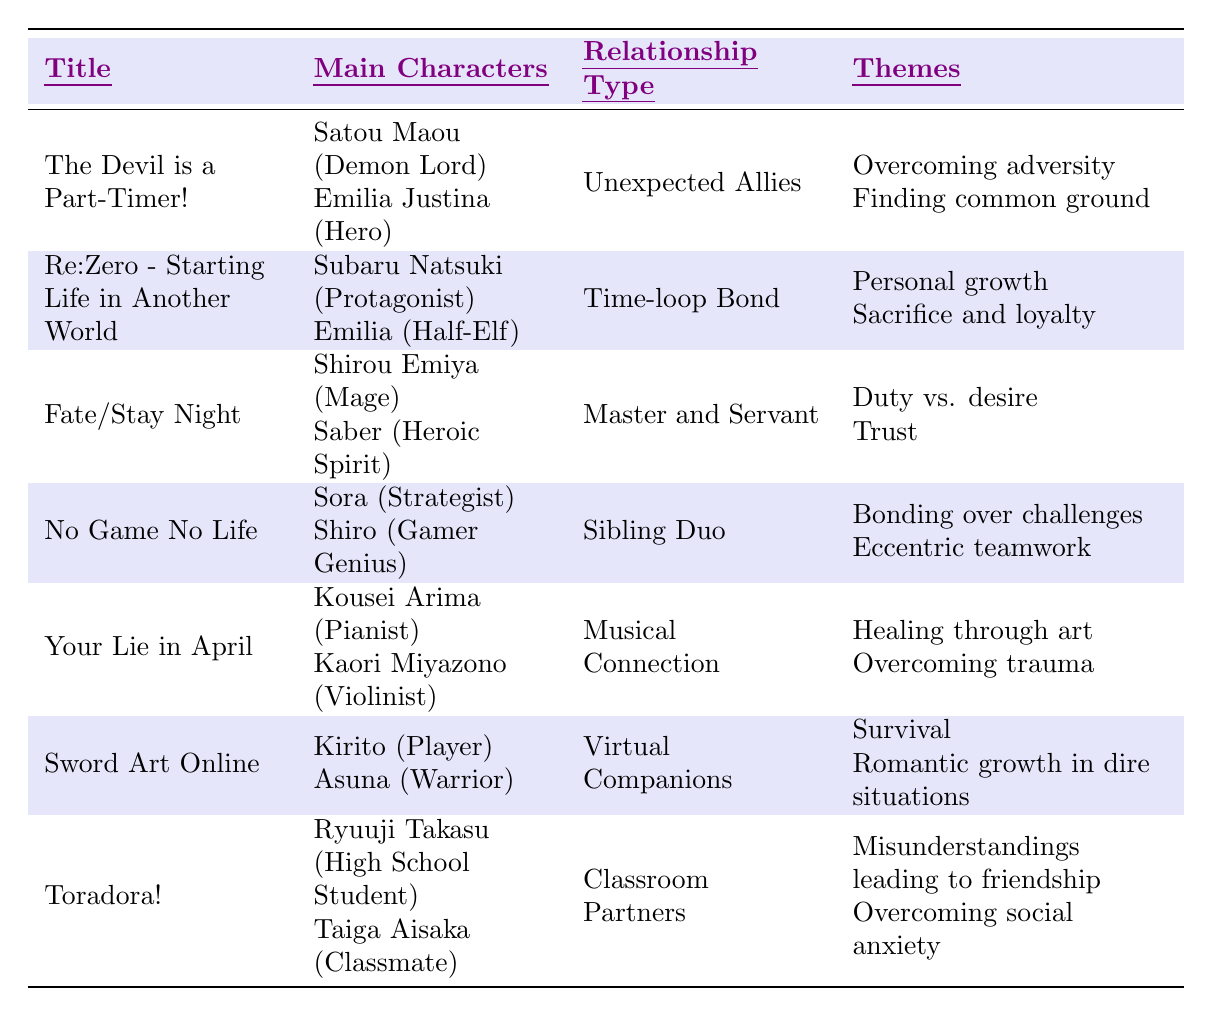What is the relationship type in "Your Lie in April"? The table shows that the relationship type in "Your Lie in April" is "Musical Connection."
Answer: Musical Connection Who are the main characters in "Sword Art Online"? According to the table, the main characters in "Sword Art Online" are Kirito (Player) and Asuna (Warrior).
Answer: Kirito and Asuna How many themes are associated with "Fate/Stay Night"? The table lists two themes for "Fate/Stay Night," which are "Duty vs. desire" and "Trust."
Answer: 2 Is "Re:Zero - Starting Life in Another World" focused on themes of personal growth? Yes, the table indicates that one of the themes is "Personal growth."
Answer: Yes Which two titles have the theme of overcoming adversity? "The Devil is a Part-Timer!" and "Your Lie in April" both have themes related to overcoming adversity.
Answer: The Devil is a Part-Timer! and Your Lie in April What is the common relationship type found in both "No Game No Life" and "Sword Art Online"? "No Game No Life" has a relationship type called "Sibling Duo," while "Sword Art Online" has "Virtual Companions." They do not share a common relationship type.
Answer: None Which title features a time-loop bond between its main characters? "Re:Zero - Starting Life in Another World" features a time-loop bond between Subaru Natsuki and Emilia.
Answer: Re:Zero - Starting Life in Another World How many titles have "Trust" listed as a theme? The table shows that only "Fate/Stay Night" has "Trust" listed as a theme, so there is one title.
Answer: 1 Which title from the table has the role of "Demon Lord"? The role of "Demon Lord" is associated with Satou Maou in "The Devil is a Part-Timer!"
Answer: The Devil is a Part-Timer! What is the difference between the themes of "Your Lie in April" and "Toradora!"? "Your Lie in April" focuses on "Healing through art" and "Overcoming trauma," while "Toradora!" centers on "Misunderstandings leading to friendship" and "Overcoming social anxiety." Thus, both titles focus on personal growth, but through different contexts.
Answer: Different contexts (art vs. friendship) In which two titles do the main characters find common ground during their relationship? "The Devil is a Part-Timer!" emphasizes finding common ground as a theme, and while "Toradora!" also highlights overcoming social anxiety, it does not specifically mention common ground.
Answer: The Devil is a Part-Timer! 